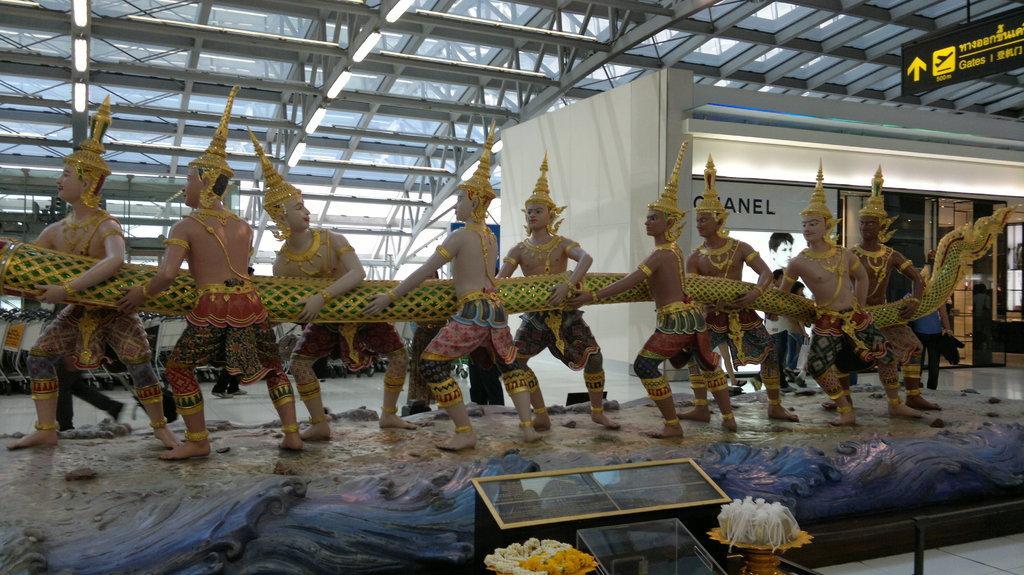In one or two sentences, can you explain what this image depicts? In this image I can see few people statue and they are holding something. I can see a white color board,flowerpot and few objects. 